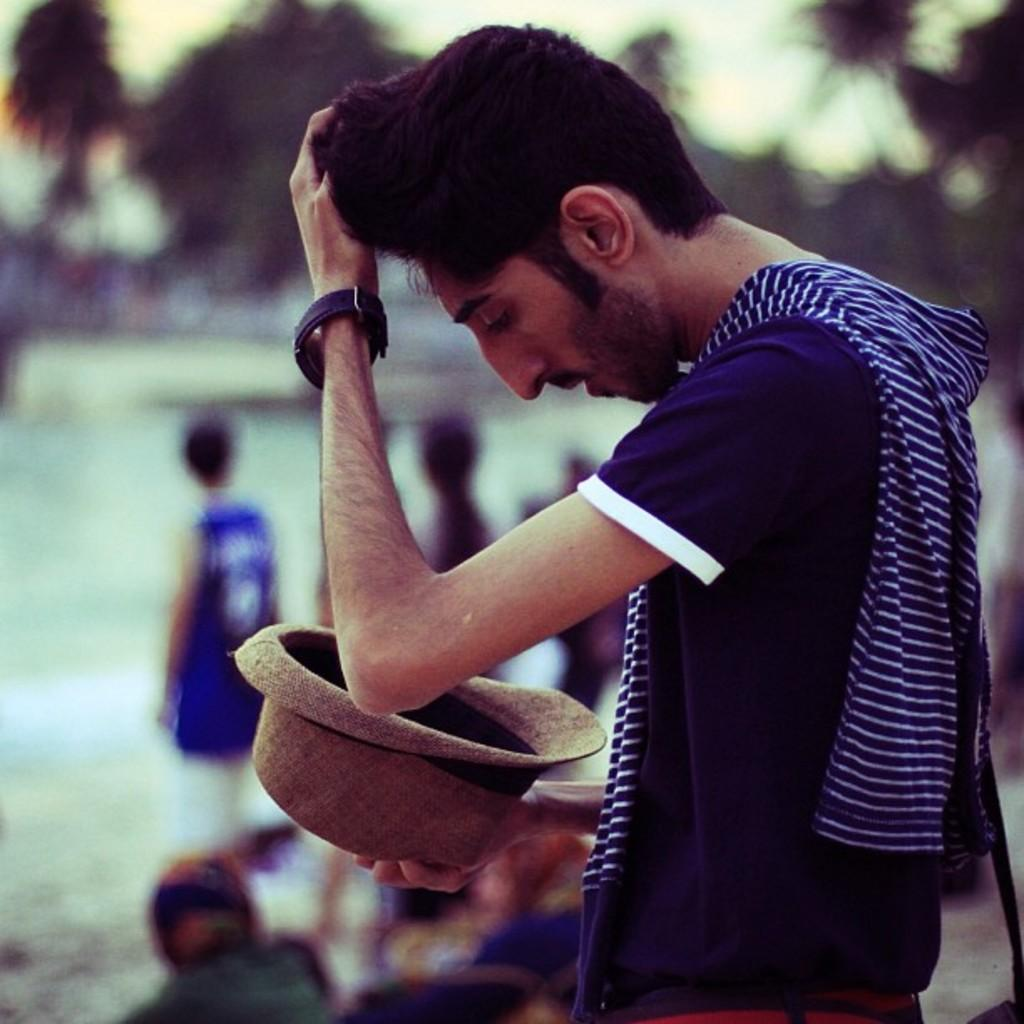What is the man in the image doing? The man is standing in the image. What is the man holding in the image? The man is holding a hat. How many people are standing in the image? There are multiple people standing in the image. What can be seen in the background of the image? There are trees visible in the image. What type of flesh can be seen on the man's face in the image? There is no flesh visible on the man's face in the image; it is a photograph, not a painting or drawing. What trick is the man performing in the image? There is no trick being performed in the image; the man is simply standing and holding a hat. 